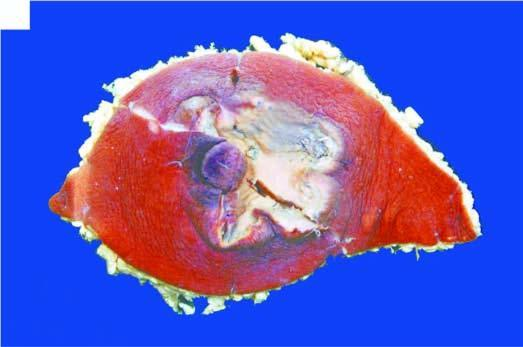what is crusted and ulcerated?
Answer the question using a single word or phrase. Region of nipple and areola 